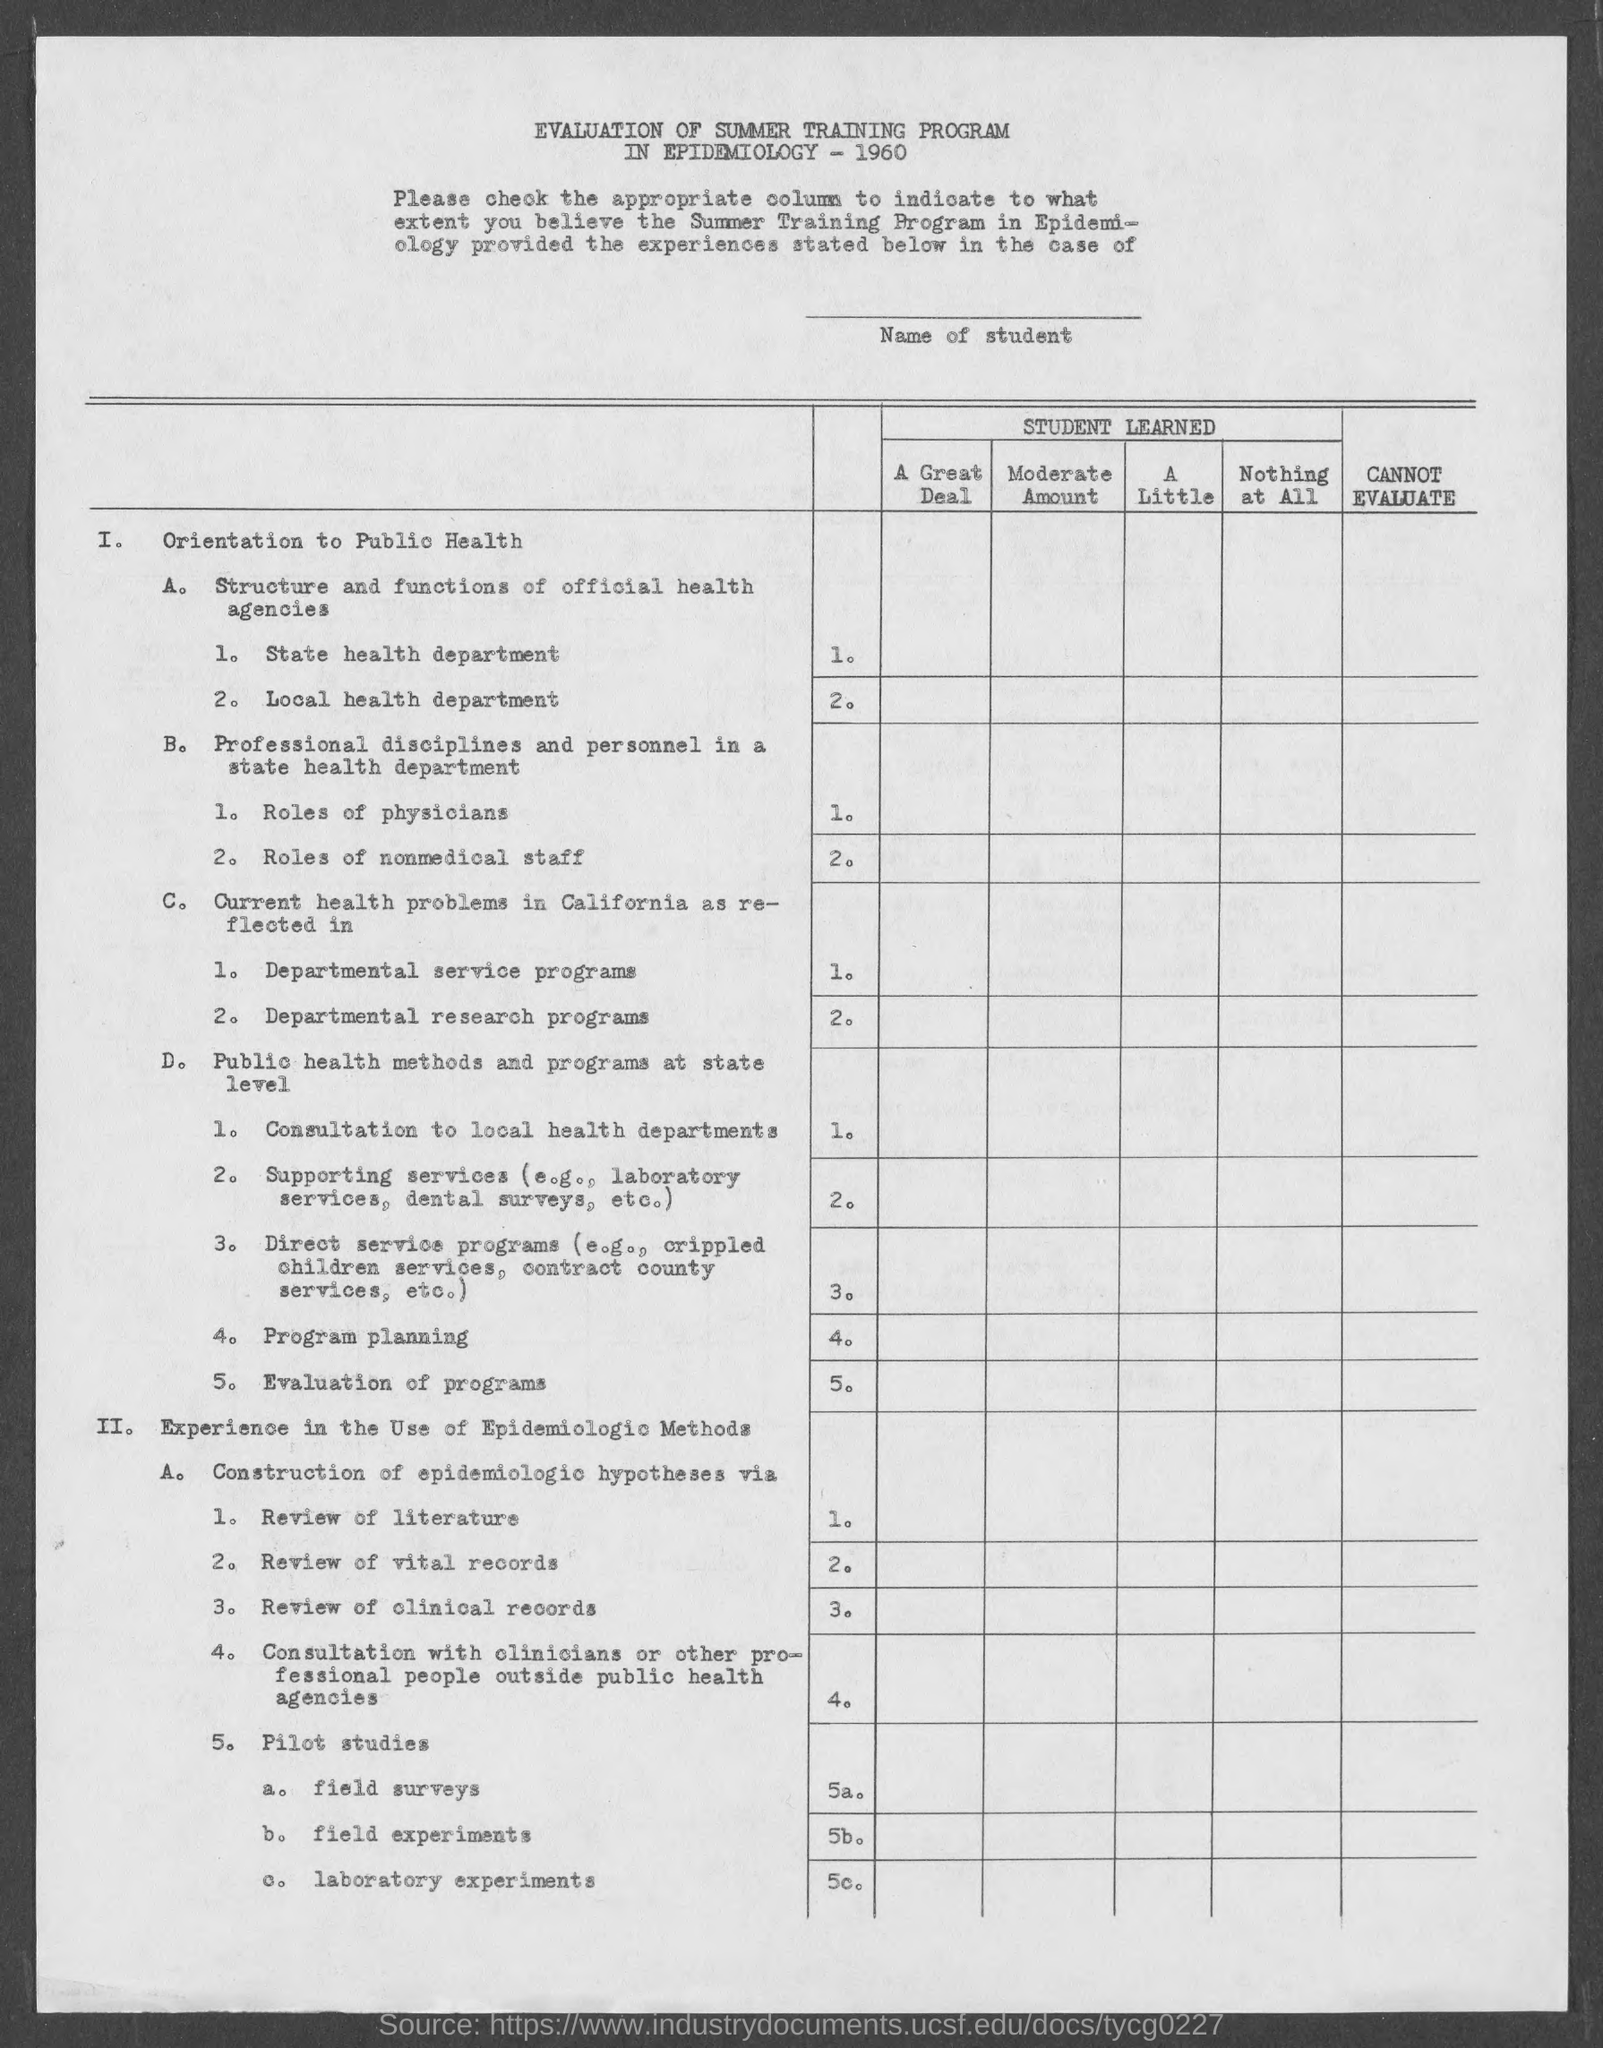Mention a couple of crucial points in this snapshot. The evaluation of the summer training program in epidemiology from the year 1960 has been completed. 